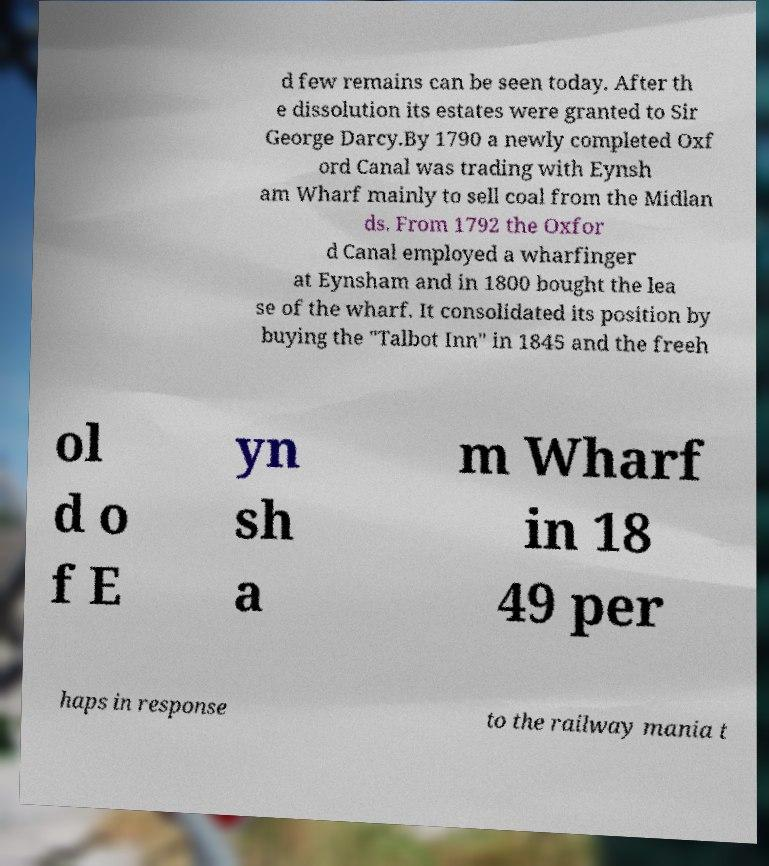Please read and relay the text visible in this image. What does it say? d few remains can be seen today. After th e dissolution its estates were granted to Sir George Darcy.By 1790 a newly completed Oxf ord Canal was trading with Eynsh am Wharf mainly to sell coal from the Midlan ds. From 1792 the Oxfor d Canal employed a wharfinger at Eynsham and in 1800 bought the lea se of the wharf. It consolidated its position by buying the "Talbot Inn" in 1845 and the freeh ol d o f E yn sh a m Wharf in 18 49 per haps in response to the railway mania t 